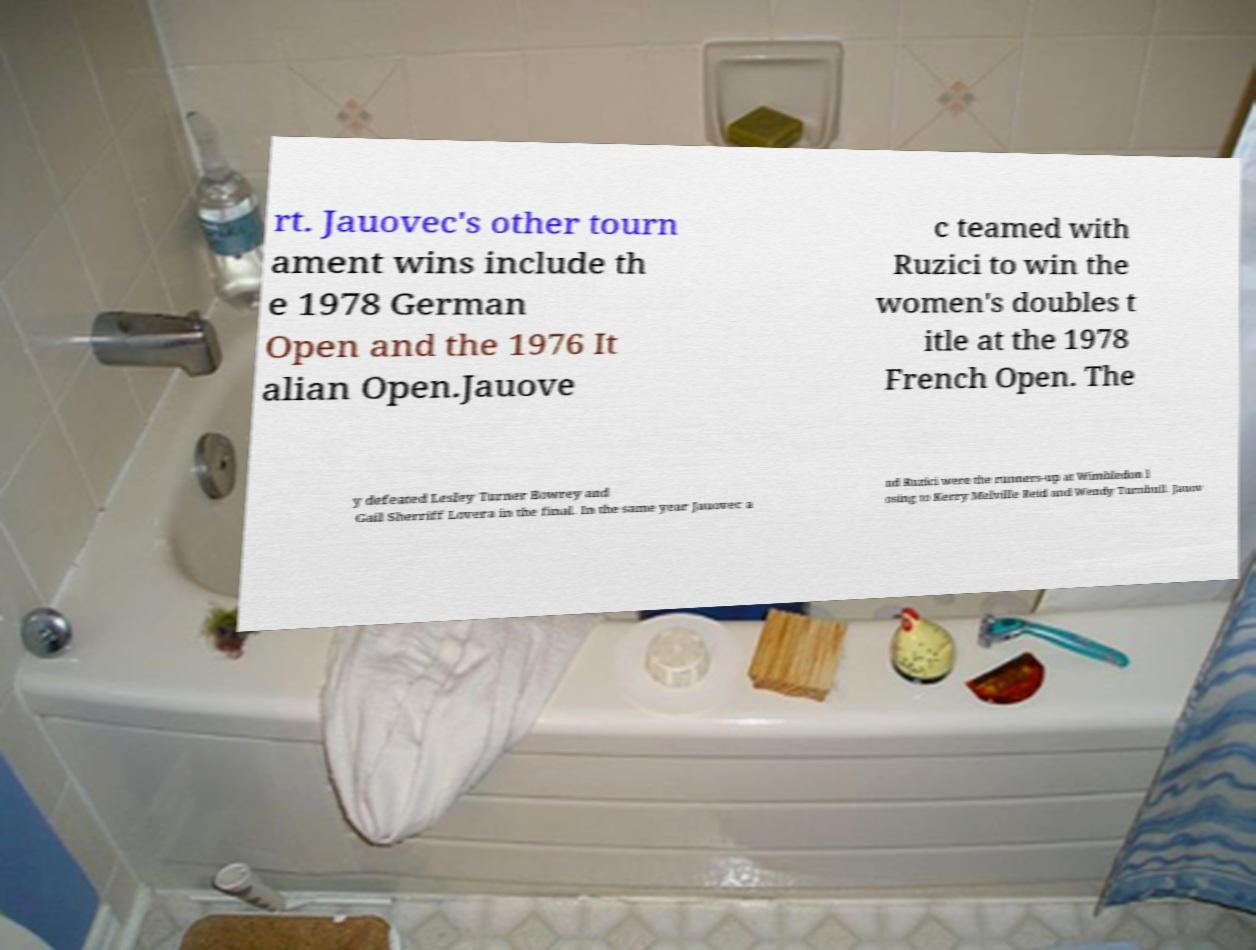What messages or text are displayed in this image? I need them in a readable, typed format. rt. Jauovec's other tourn ament wins include th e 1978 German Open and the 1976 It alian Open.Jauove c teamed with Ruzici to win the women's doubles t itle at the 1978 French Open. The y defeated Lesley Turner Bowrey and Gail Sherriff Lovera in the final. In the same year Jauovec a nd Ruzici were the runners-up at Wimbledon l osing to Kerry Melville Reid and Wendy Turnbull. Jauov 